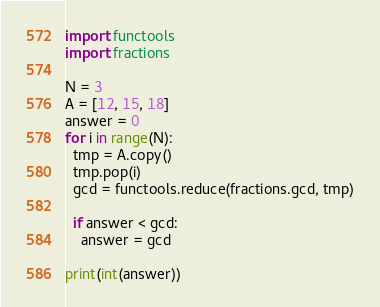<code> <loc_0><loc_0><loc_500><loc_500><_Python_>import functools
import fractions

N = 3
A = [12, 15, 18]
answer = 0
for i in range(N):
  tmp = A.copy()
  tmp.pop(i)
  gcd = functools.reduce(fractions.gcd, tmp)
  
  if answer < gcd:
    answer = gcd

print(int(answer))</code> 